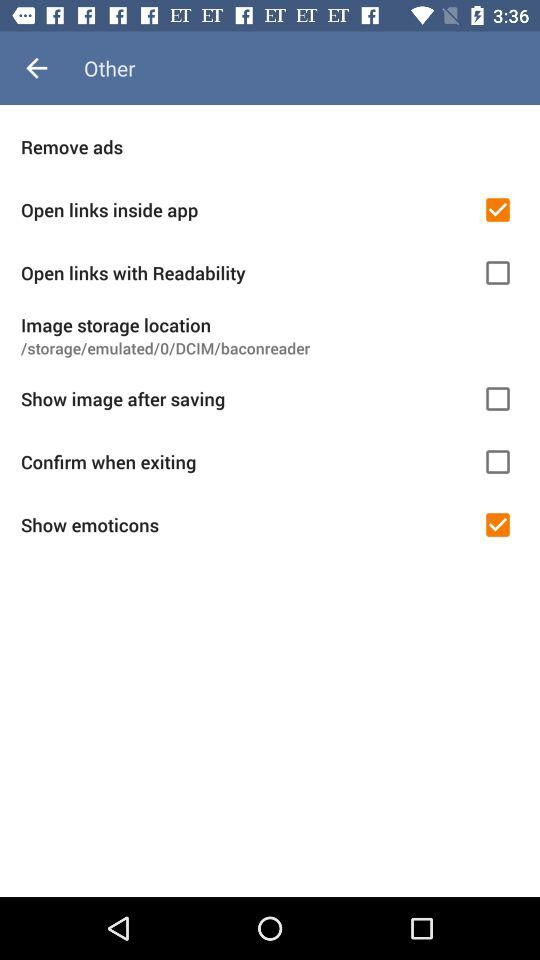Which is the selected checkbox? The selected checkboxes are "Open links inside app" and "Show emoticons". 